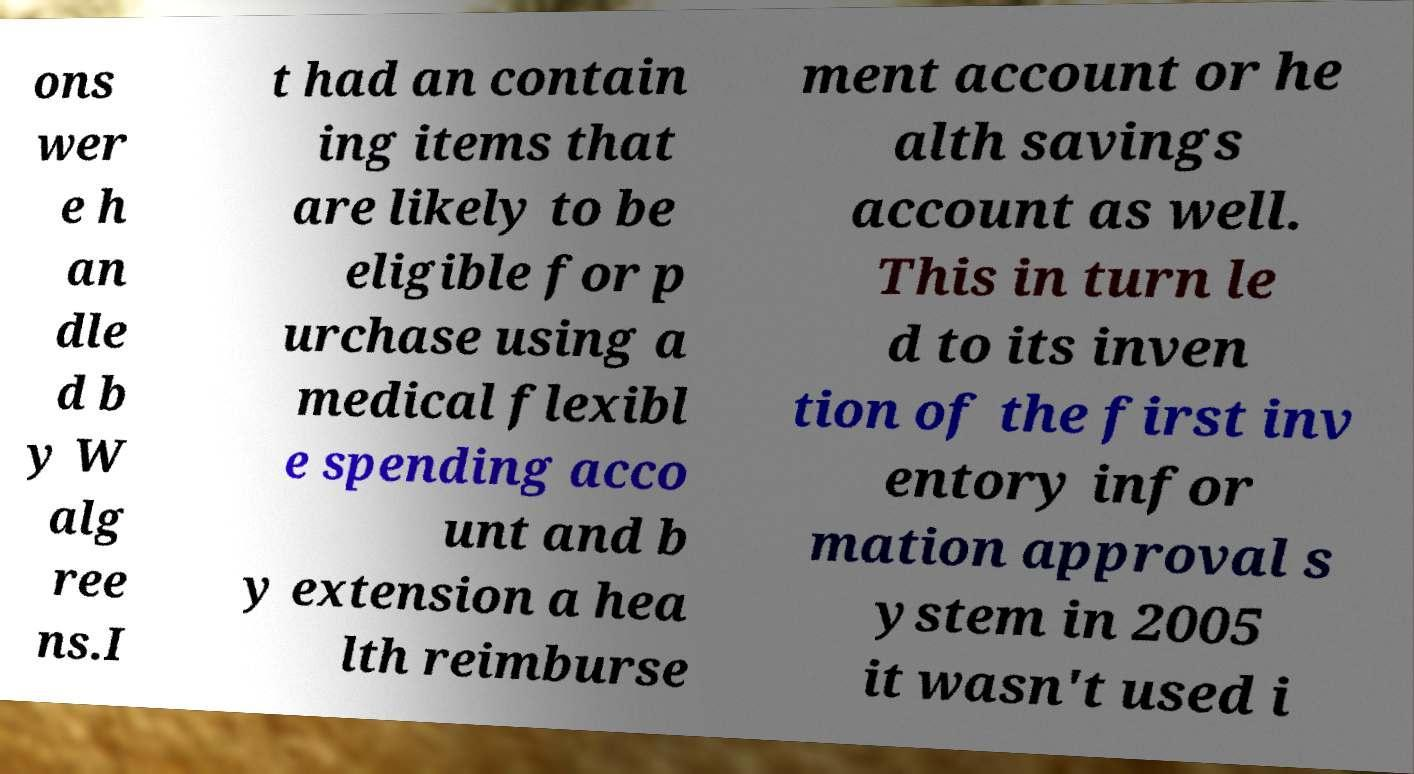Could you extract and type out the text from this image? ons wer e h an dle d b y W alg ree ns.I t had an contain ing items that are likely to be eligible for p urchase using a medical flexibl e spending acco unt and b y extension a hea lth reimburse ment account or he alth savings account as well. This in turn le d to its inven tion of the first inv entory infor mation approval s ystem in 2005 it wasn't used i 